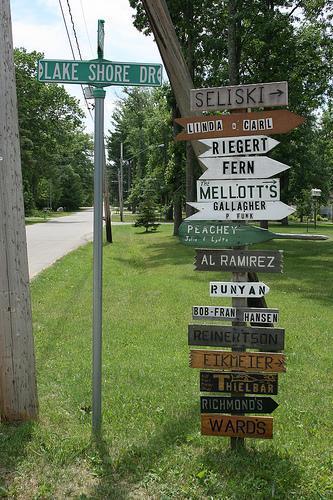How many wooden signs are there?
Give a very brief answer. 15. 